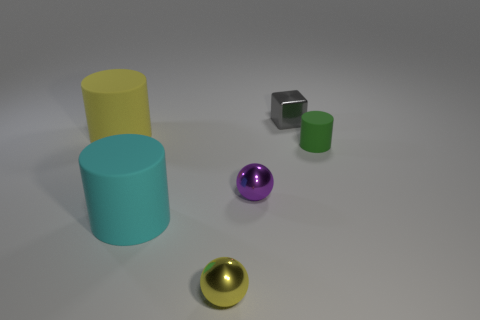There is a cyan rubber cylinder; are there any tiny green cylinders behind it?
Give a very brief answer. Yes. The rubber thing that is right of the tiny metal object behind the small object that is on the right side of the gray object is what color?
Make the answer very short. Green. Do the big cyan matte object and the gray thing have the same shape?
Offer a very short reply. No. What color is the large object that is the same material as the cyan cylinder?
Offer a very short reply. Yellow. What number of things are either small spheres that are on the right side of the large cyan matte cylinder or small gray metal cubes?
Provide a succinct answer. 3. There is a green object in front of the big yellow cylinder; what size is it?
Offer a very short reply. Small. Do the green rubber cylinder and the shiny object that is in front of the large cyan thing have the same size?
Ensure brevity in your answer.  Yes. The metal object that is behind the big matte cylinder that is behind the purple metallic sphere is what color?
Provide a succinct answer. Gray. How many other things are the same color as the small metallic block?
Keep it short and to the point. 0. What is the size of the purple metallic object?
Provide a succinct answer. Small. 